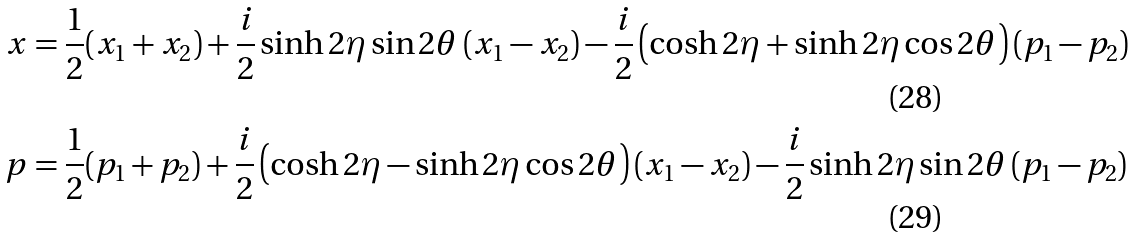<formula> <loc_0><loc_0><loc_500><loc_500>x & = \frac { 1 } { 2 } ( x _ { 1 } + x _ { 2 } ) + \frac { i } { 2 } \sinh 2 \eta \sin 2 \theta \, ( x _ { 1 } - x _ { 2 } ) - \frac { i } { 2 } \left ( \cosh 2 \eta + \sinh 2 \eta \cos 2 \theta \right ) ( p _ { 1 } - p _ { 2 } ) \\ p & = \frac { 1 } { 2 } ( p _ { 1 } + p _ { 2 } ) + \frac { i } { 2 } \left ( \cosh 2 \eta - \sinh 2 \eta \cos 2 \theta \right ) ( x _ { 1 } - x _ { 2 } ) - \frac { i } { 2 } \sinh 2 \eta \sin 2 \theta \, ( p _ { 1 } - p _ { 2 } )</formula> 